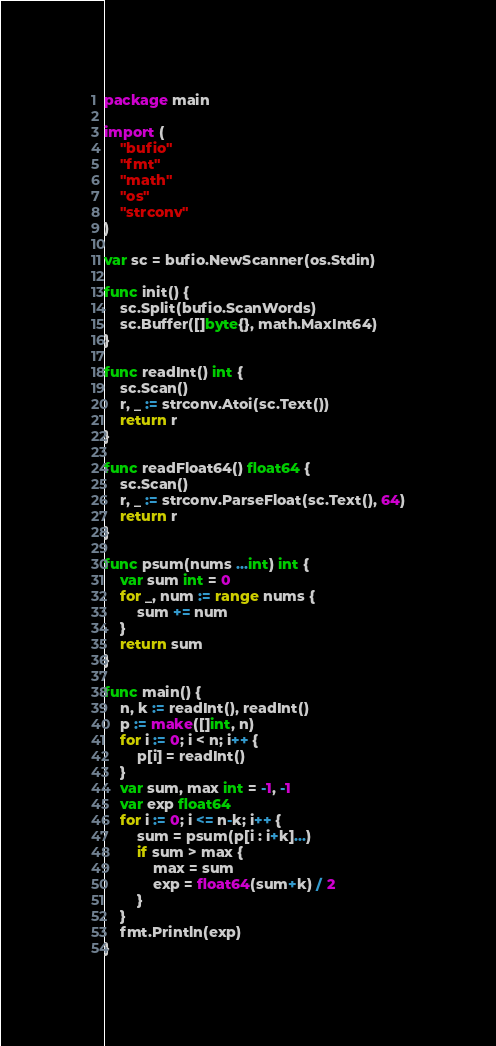Convert code to text. <code><loc_0><loc_0><loc_500><loc_500><_Go_>package main

import (
	"bufio"
	"fmt"
	"math"
	"os"
	"strconv"
)

var sc = bufio.NewScanner(os.Stdin)

func init() {
	sc.Split(bufio.ScanWords)
	sc.Buffer([]byte{}, math.MaxInt64)
}

func readInt() int {
	sc.Scan()
	r, _ := strconv.Atoi(sc.Text())
	return r
}

func readFloat64() float64 {
	sc.Scan()
	r, _ := strconv.ParseFloat(sc.Text(), 64)
	return r
}

func psum(nums ...int) int {
	var sum int = 0
	for _, num := range nums {
		sum += num
	}
	return sum
}

func main() {
	n, k := readInt(), readInt()
	p := make([]int, n)
	for i := 0; i < n; i++ {
		p[i] = readInt()
	}
	var sum, max int = -1, -1
	var exp float64
	for i := 0; i <= n-k; i++ {
		sum = psum(p[i : i+k]...)
		if sum > max {
			max = sum
			exp = float64(sum+k) / 2
		}
	}
	fmt.Println(exp)
}
</code> 